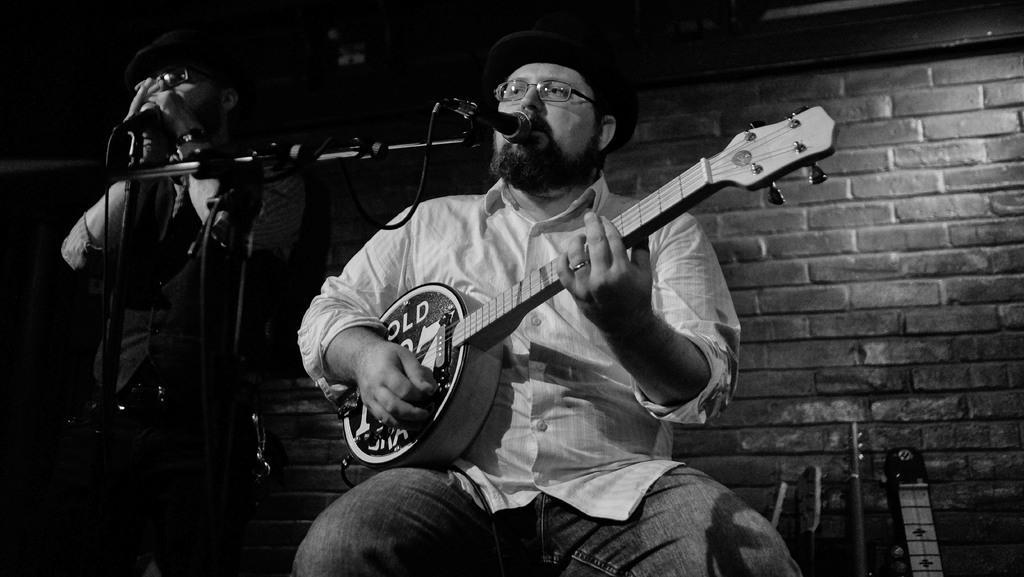In one or two sentences, can you explain what this image depicts? In this image there is are two persons. In front the person is siting on the table and playing the musical instrument. On the left side there is a person standing and holding a mic. There is mic stand. At the background there is brick wall. 